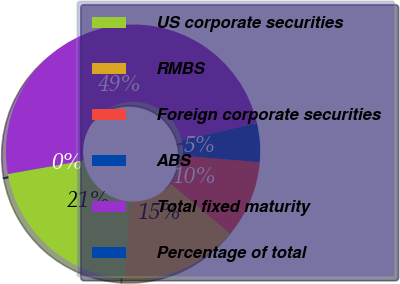<chart> <loc_0><loc_0><loc_500><loc_500><pie_chart><fcel>US corporate securities<fcel>RMBS<fcel>Foreign corporate securities<fcel>ABS<fcel>Total fixed maturity<fcel>Percentage of total<nl><fcel>21.26%<fcel>14.77%<fcel>9.85%<fcel>4.94%<fcel>49.17%<fcel>0.02%<nl></chart> 